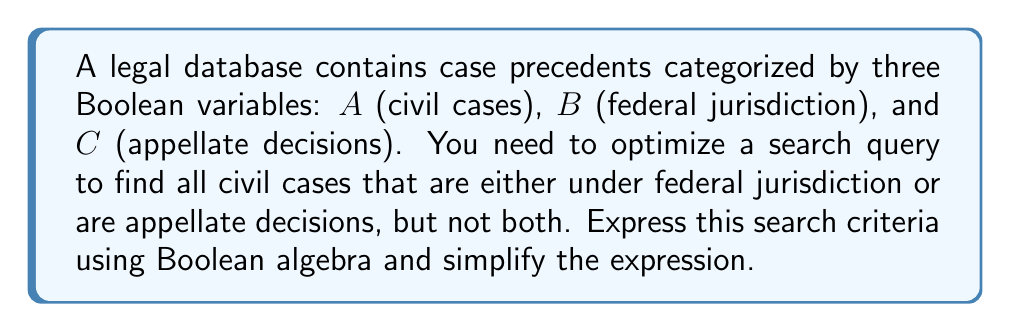Can you solve this math problem? To solve this problem, we'll follow these steps:

1) First, let's translate the search criteria into a Boolean expression:
   - We want civil cases: $A$
   - That are either federal jurisdiction or appellate decisions, but not both:
     This is an XOR operation between $B$ and $C$

2) The XOR operation can be expressed as: $(B \wedge \neg C) \vee (\neg B \wedge C)$

3) So, our initial Boolean expression is:
   $A \wedge [(B \wedge \neg C) \vee (\neg B \wedge C)]$

4) Let's simplify this expression using Boolean algebra laws:
   
   $A \wedge [(B \wedge \neg C) \vee (\neg B \wedge C)]$
   
   $= A \wedge [B \oplus C]$ (definition of XOR)
   
   This is already in its simplest form.

5) In terms of database search optimization, this expression means:
   - Filter for civil cases (A)
   - Within those results, find cases that are either federal jurisdiction or appellate decisions, but not both (B XOR C)
Answer: $A \wedge (B \oplus C)$ 